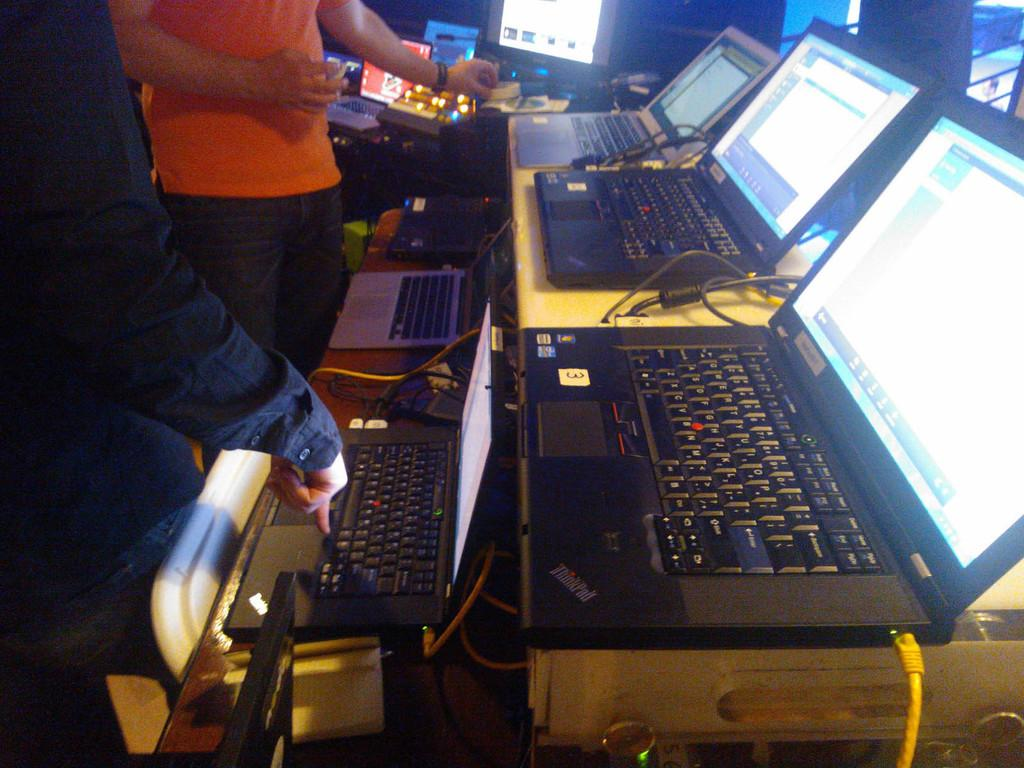<image>
Provide a brief description of the given image. A series of laptops side by side one of which has a sticker with the number 3 on it. 